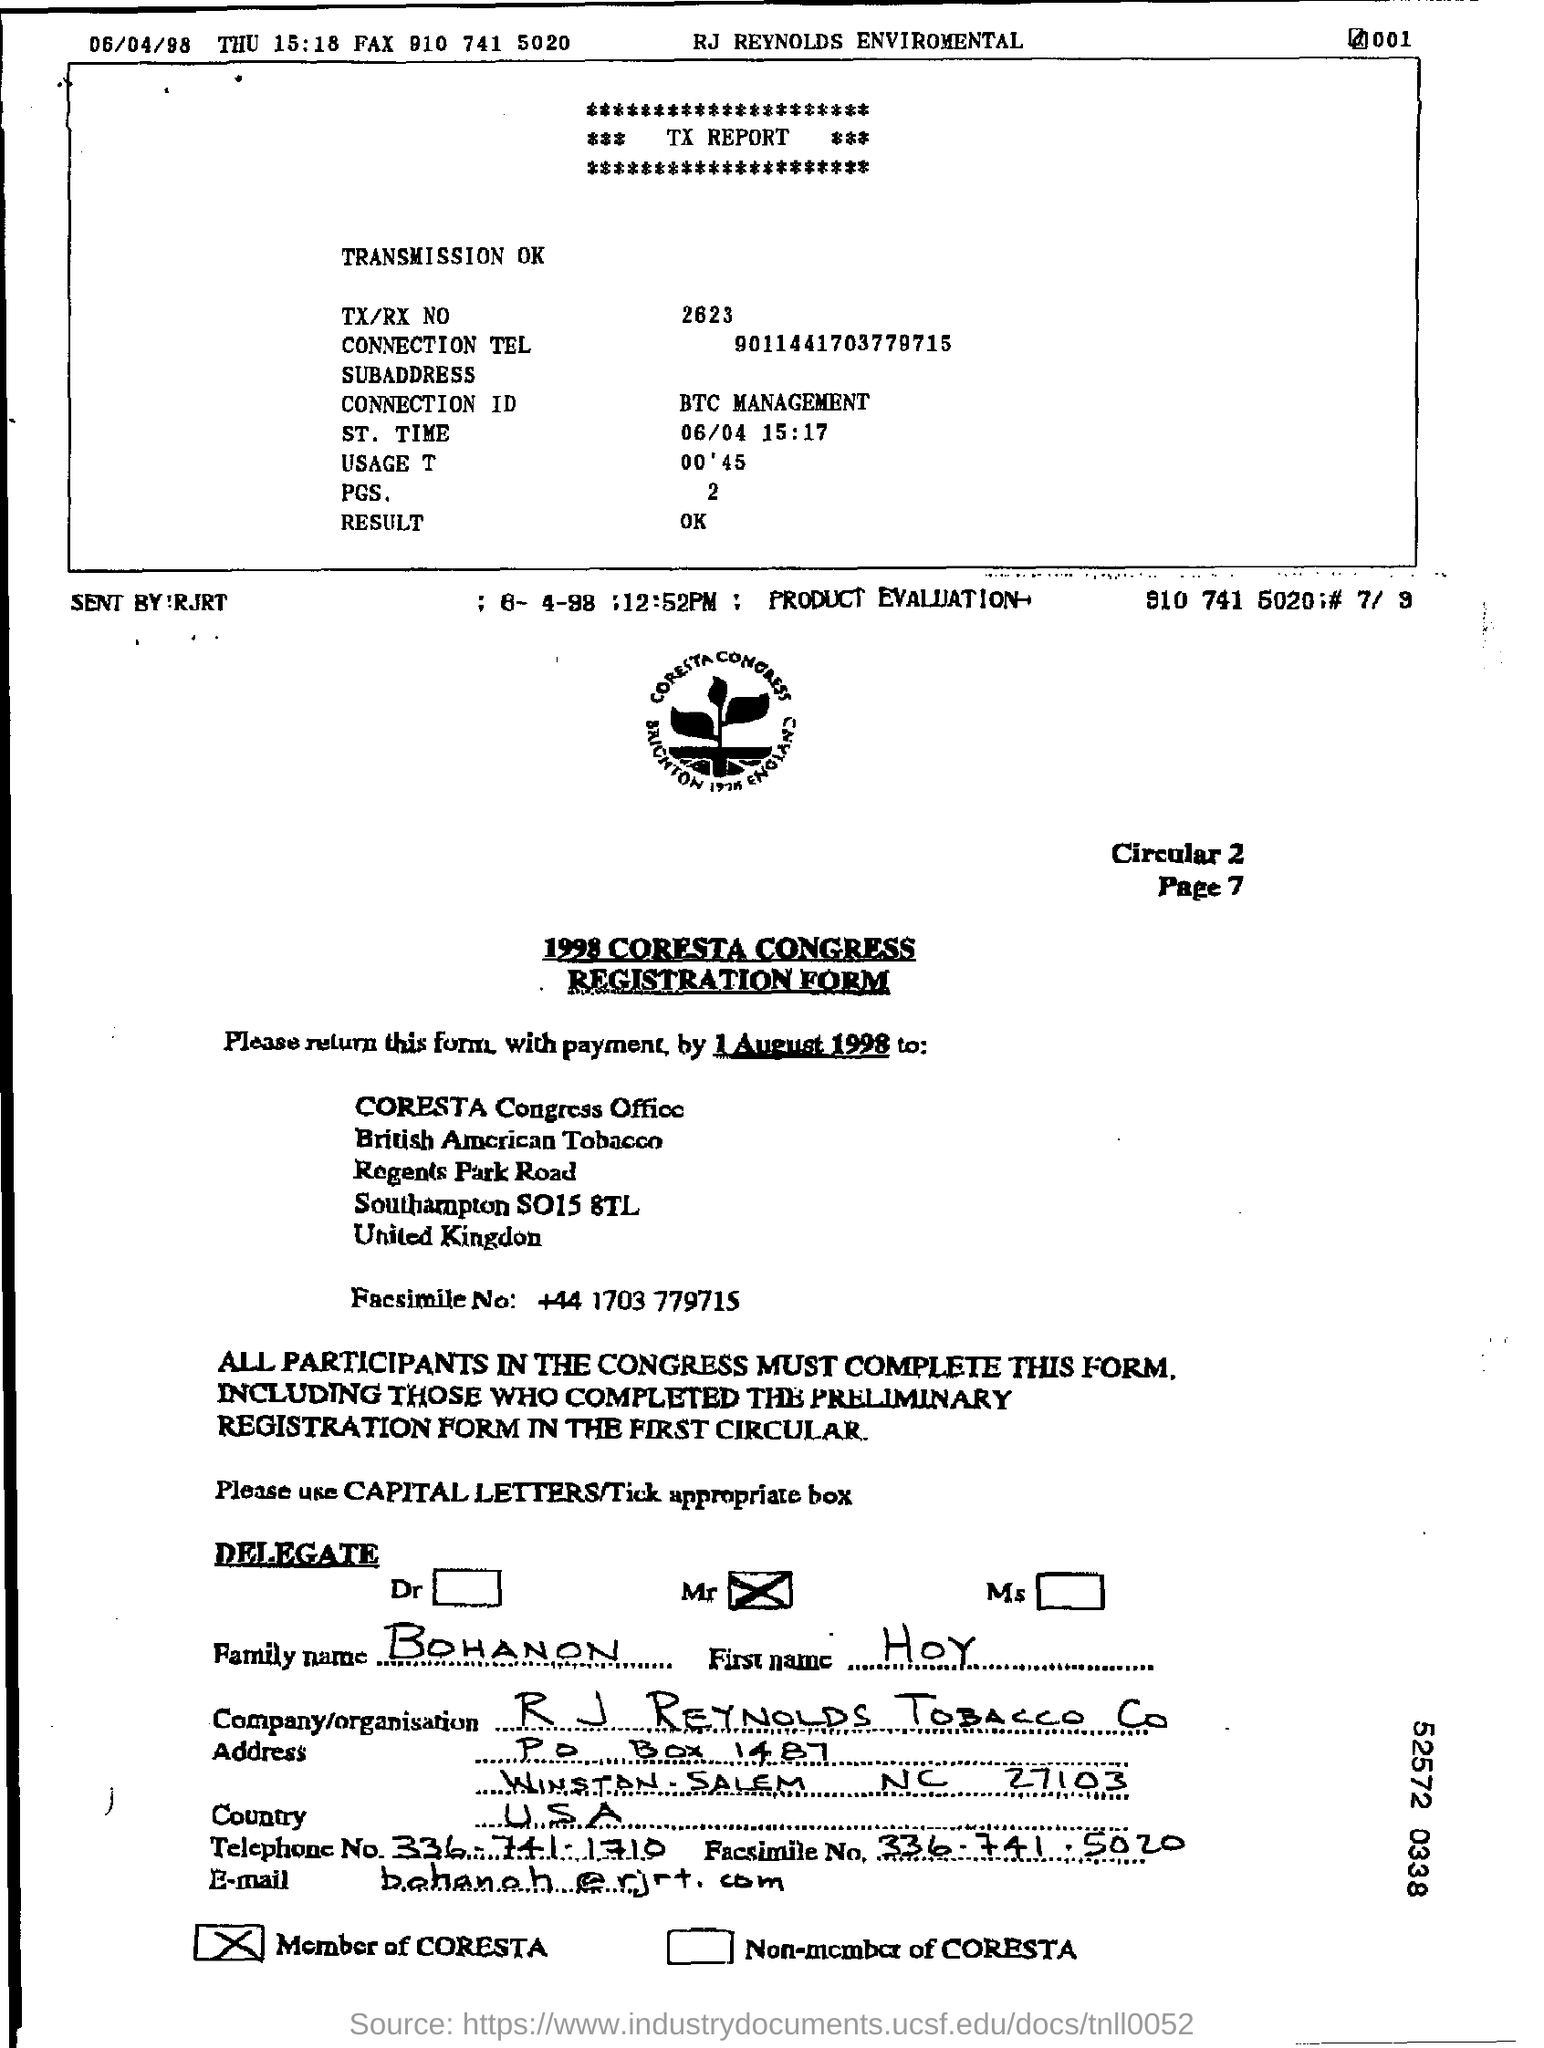What is the tx/rx no ?
Your answer should be compact. 2623. What is the connection tel number ?
Provide a succinct answer. 9011441703779715. What is the st. time of the tx report ?
Offer a very short reply. 06/04 15:17. How many pages are there in the report ?
Your answer should be compact. 2. What is the connection id mentioned in the report ?
Your response must be concise. BTC MANAGEMENT. What is the family name written in the registration form ?
Provide a short and direct response. BOHANON. What is the first name written in the form ?
Offer a terse response. HOY. What is the name of the company/ organisation written in the registration form ?
Offer a terse response. R J Reynolds Tobacco Co. What is the name of the country written in the registration form ?
Your response must be concise. USA. What is the telephone no written in the form ?
Make the answer very short. 336-741-1710. 